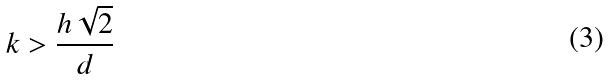<formula> <loc_0><loc_0><loc_500><loc_500>k > \frac { h \sqrt { 2 } } { d }</formula> 